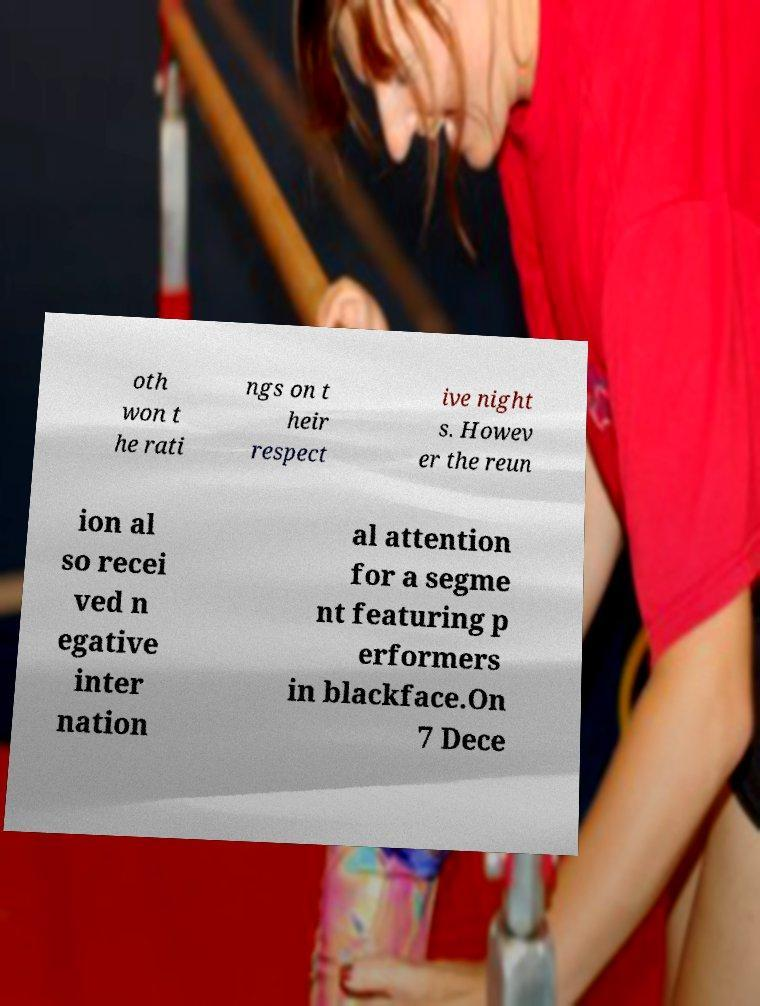Could you assist in decoding the text presented in this image and type it out clearly? oth won t he rati ngs on t heir respect ive night s. Howev er the reun ion al so recei ved n egative inter nation al attention for a segme nt featuring p erformers in blackface.On 7 Dece 